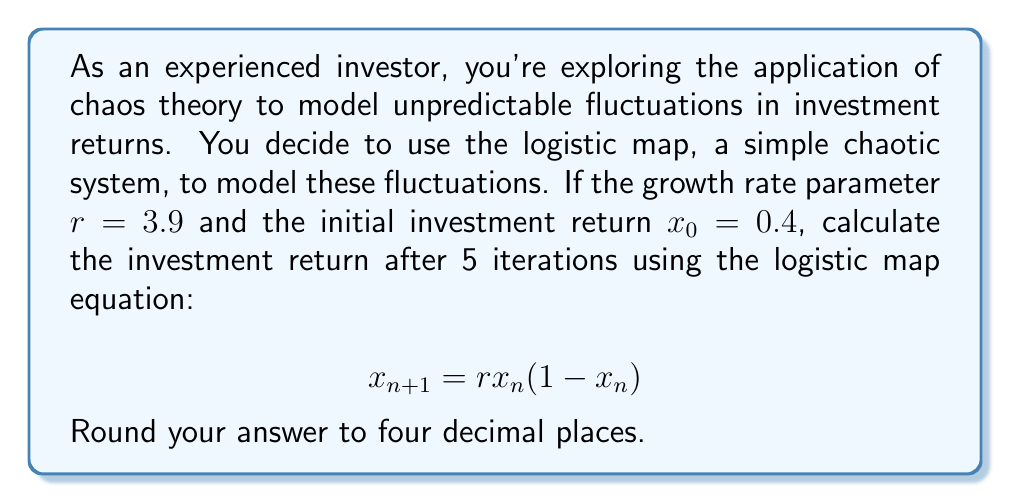Help me with this question. Let's calculate the investment return step by step using the logistic map equation:

1) We start with $r = 3.9$ and $x_0 = 0.4$

2) First iteration:
   $x_1 = 3.9 \cdot 0.4 \cdot (1-0.4) = 3.9 \cdot 0.4 \cdot 0.6 = 0.936$

3) Second iteration:
   $x_2 = 3.9 \cdot 0.936 \cdot (1-0.936) = 3.9 \cdot 0.936 \cdot 0.064 = 0.2340864$

4) Third iteration:
   $x_3 = 3.9 \cdot 0.2340864 \cdot (1-0.2340864) = 3.9 \cdot 0.2340864 \cdot 0.7659136 = 0.6988976$

5) Fourth iteration:
   $x_4 = 3.9 \cdot 0.6988976 \cdot (1-0.6988976) = 3.9 \cdot 0.6988976 \cdot 0.3011024 = 0.8219595$

6) Fifth iteration:
   $x_5 = 3.9 \cdot 0.8219595 \cdot (1-0.8219595) = 3.9 \cdot 0.8219595 \cdot 0.1780405 = 0.5708981$

7) Rounding to four decimal places: 0.5709

This demonstrates how a simple deterministic system can produce seemingly random results, modeling the unpredictable nature of investment returns.
Answer: 0.5709 